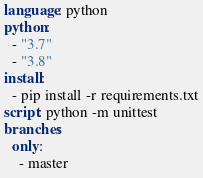Convert code to text. <code><loc_0><loc_0><loc_500><loc_500><_YAML_>language: python
python:
  - "3.7"
  - "3.8"
install:
  - pip install -r requirements.txt
script: python -m unittest
branches:
  only:
    - master</code> 